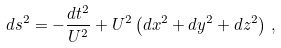Convert formula to latex. <formula><loc_0><loc_0><loc_500><loc_500>d s ^ { 2 } = - \frac { d t ^ { 2 } } { U ^ { 2 } } + U ^ { 2 } \left ( d x ^ { 2 } + d y ^ { 2 } + d z ^ { 2 } \right ) \, ,</formula> 